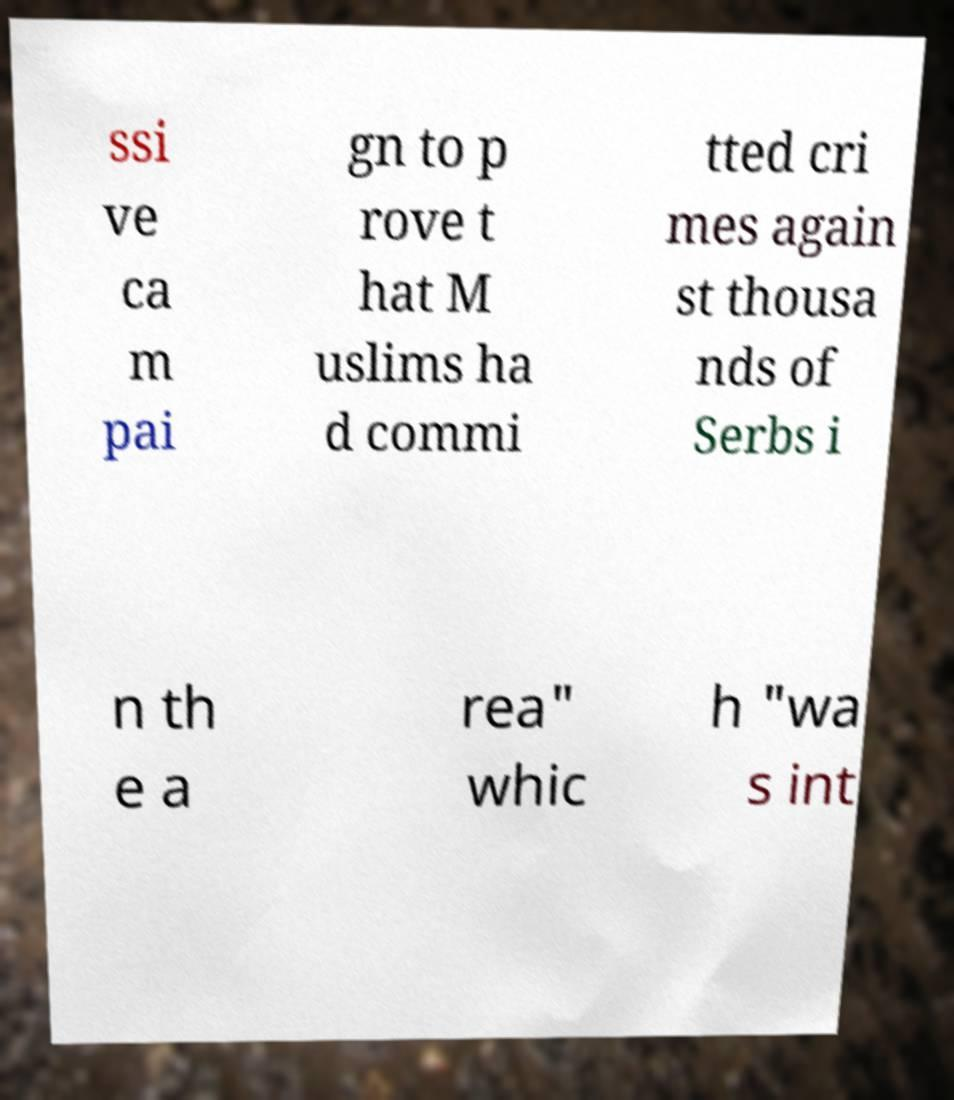I need the written content from this picture converted into text. Can you do that? ssi ve ca m pai gn to p rove t hat M uslims ha d commi tted cri mes again st thousa nds of Serbs i n th e a rea" whic h "wa s int 